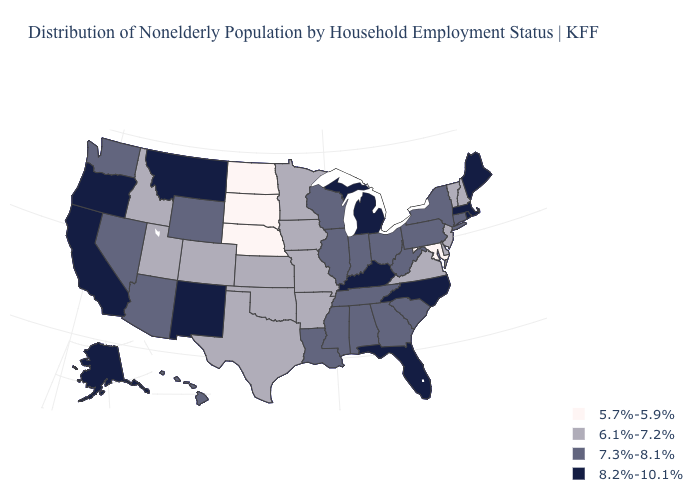Does Iowa have the lowest value in the USA?
Keep it brief. No. What is the value of Michigan?
Quick response, please. 8.2%-10.1%. Does Ohio have the same value as Washington?
Write a very short answer. Yes. Does Wyoming have the same value as Colorado?
Give a very brief answer. No. Which states have the lowest value in the MidWest?
Concise answer only. Nebraska, North Dakota, South Dakota. What is the lowest value in the South?
Quick response, please. 5.7%-5.9%. Name the states that have a value in the range 7.3%-8.1%?
Answer briefly. Alabama, Arizona, Connecticut, Georgia, Hawaii, Illinois, Indiana, Louisiana, Mississippi, Nevada, New York, Ohio, Pennsylvania, South Carolina, Tennessee, Washington, West Virginia, Wisconsin, Wyoming. Does the map have missing data?
Answer briefly. No. What is the lowest value in states that border Georgia?
Short answer required. 7.3%-8.1%. What is the value of Maine?
Be succinct. 8.2%-10.1%. What is the lowest value in the West?
Answer briefly. 6.1%-7.2%. What is the value of Virginia?
Quick response, please. 6.1%-7.2%. What is the highest value in the Northeast ?
Answer briefly. 8.2%-10.1%. How many symbols are there in the legend?
Quick response, please. 4. Does Alaska have the highest value in the USA?
Quick response, please. Yes. 